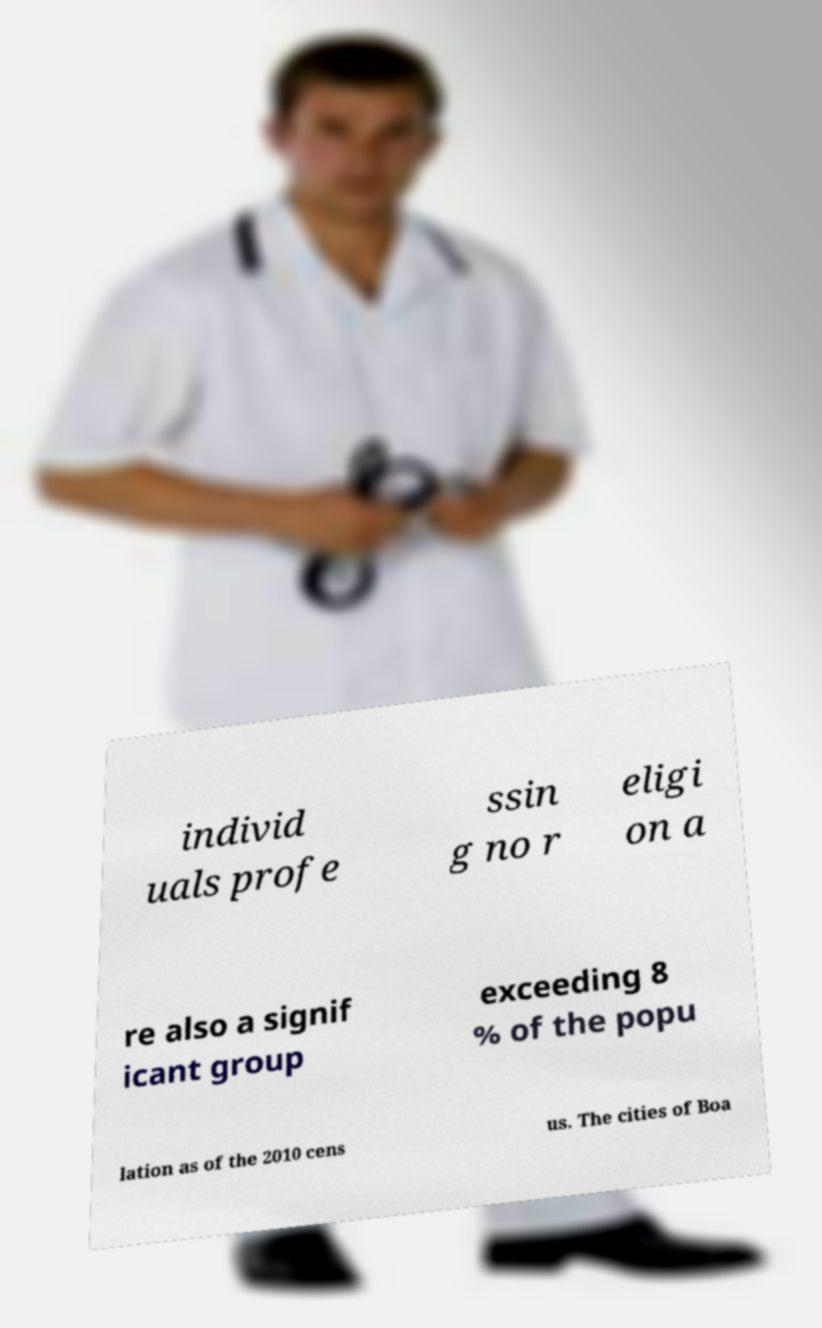Can you read and provide the text displayed in the image?This photo seems to have some interesting text. Can you extract and type it out for me? individ uals profe ssin g no r eligi on a re also a signif icant group exceeding 8 % of the popu lation as of the 2010 cens us. The cities of Boa 